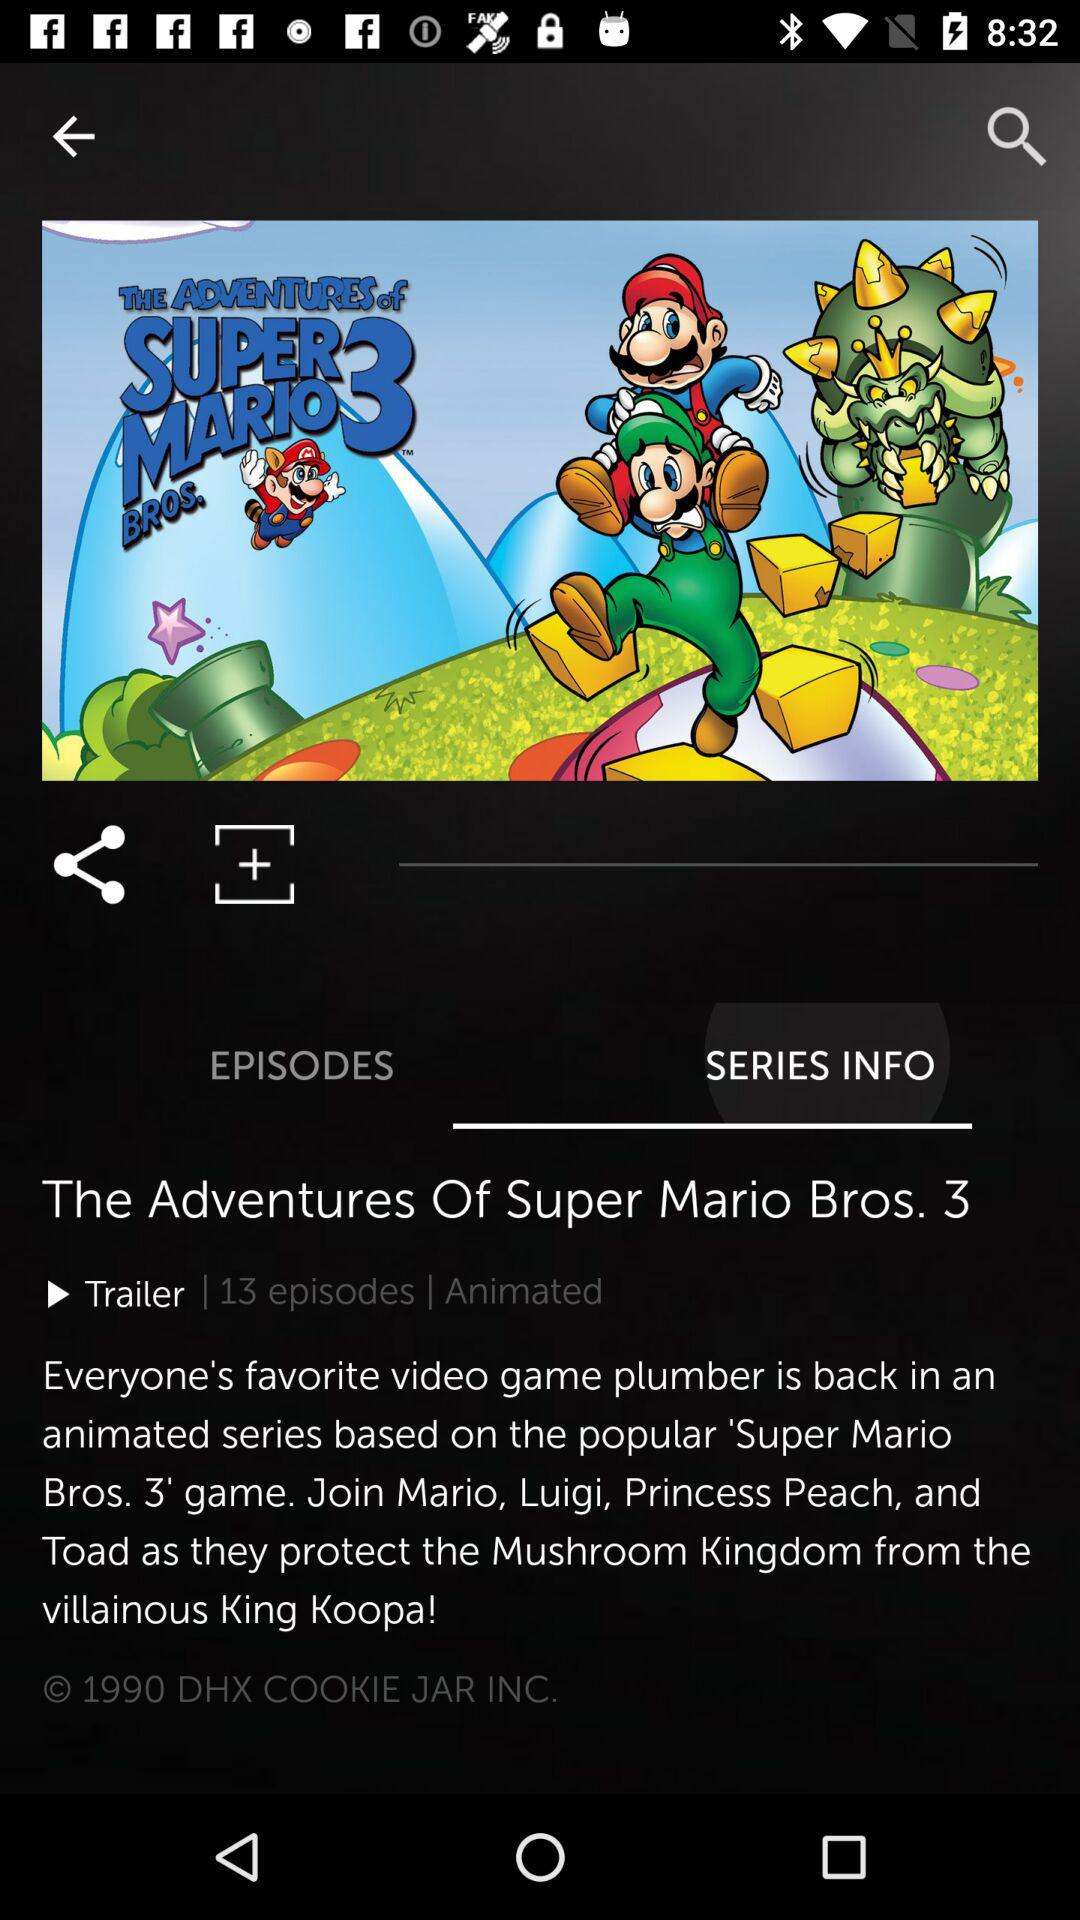What type of series is "The Adventures Of Super Mario Bros. 3"? It is an animated series. 